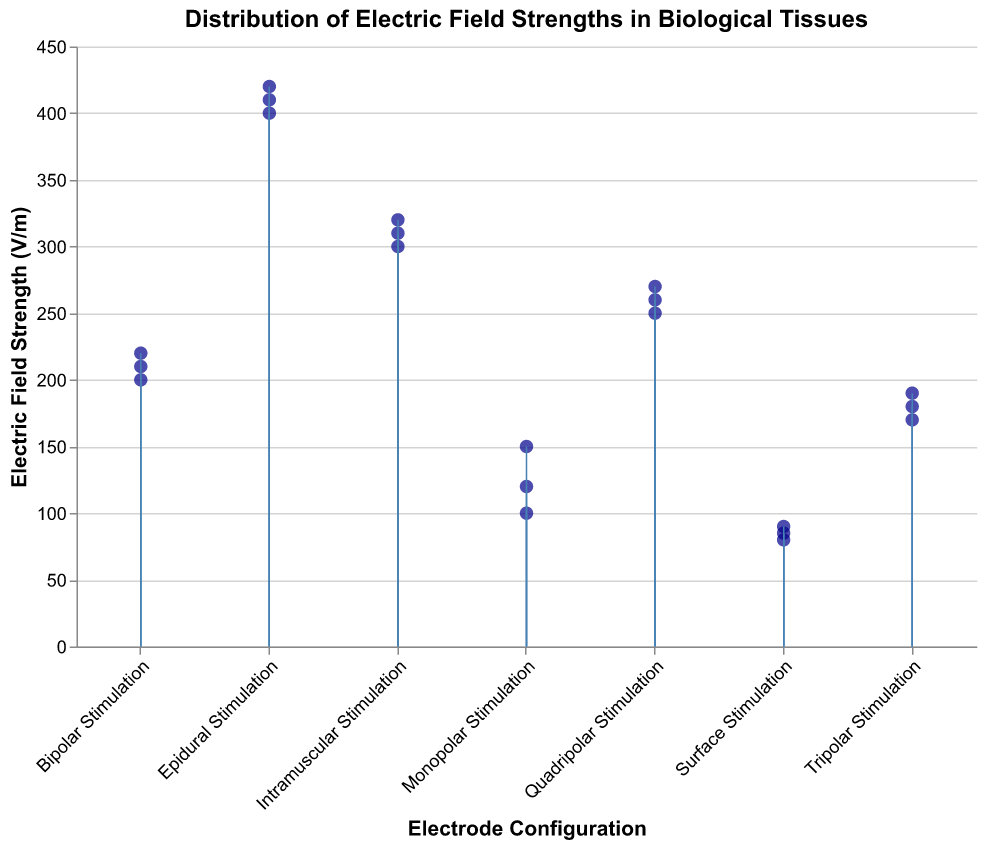What's the title of the figure? The title of the figure is shown at the top and is typically in a larger font.
Answer: Distribution of Electric Field Strengths in Biological Tissues What is the range of Electric Field Strengths for Intramuscular Stimulation? The range can be determined by looking at the minimum and maximum Electric Field Strength values for Intramuscular Stimulation.
Answer: 300 V/m to 320 V/m How many data points are there for each Electrode Configuration? Count the number of stem points for each Electrode Configuration in the plot. Each configuration should have a cluster of points.
Answer: Three data points per configuration Which Electrode Configuration has the highest Electric Field Strength? Compare the highest points among all the Electrode Configurations. The configuration with the highest data point represents the maximum Electric Field Strength.
Answer: Epidural Stimulation What is the average Electric Field Strength for Quadripolar Stimulation? Sum the Electric Field Strength values for Quadripolar Stimulation and divide by the number of data points (three). (250 + 270 + 260) / 3 = 260
Answer: 260 V/m What is the difference in the Electric Field Strength between the highest value of Bipolar Stimulation and the lowest value of Tripolar Stimulation? Identify the highest value for Bipolar Stimulation (220 V/m) and the lowest value for Tripolar Stimulation (170 V/m), then subtract the latter from the former. 220 - 170 = 50
Answer: 50 V/m Which Electrode Configuration shows the most variation in Electric Field Strength? The variation can be assessed by observing the spread of points in each grouping. The Electrode Configuration with the widest spread shows the most variation.
Answer: Epidural Stimulation What color are the data points in the plot? The color can be identified by visually inspecting the appearance of the points in the plot.
Answer: Dark blue Are Electric Field Strengths for Bipolar Stimulation higher than those for Surface Stimulation? Compare the range of Electric Field Strengths for Bipolar Stimulation (200 - 220 V/m) and Surface Stimulation (80 - 90 V/m).
Answer: Yes, higher What is the median Electric Field Strength for Monopolar Stimulation? Arrange the Electric Field Strength values for Monopolar Stimulation in ascending order and identify the middle value. The values are 100, 120, and 150, so the median is 120.
Answer: 120 V/m 